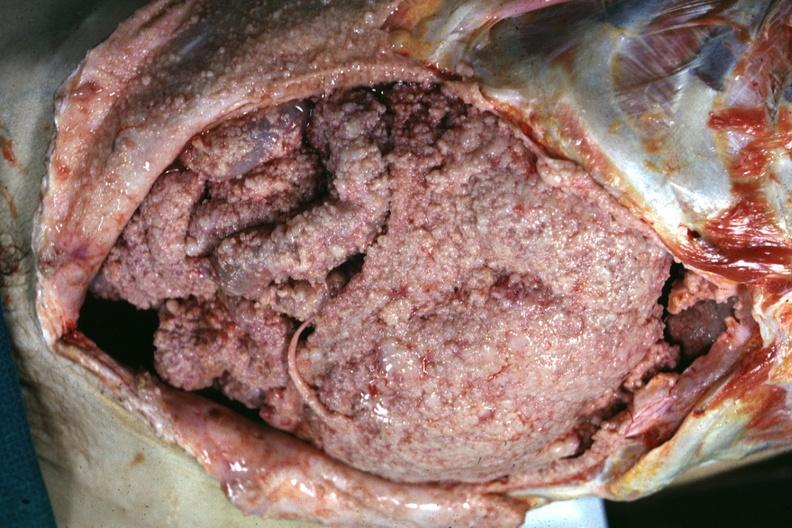does this image show opened abdomen showing tumor everywhere this also could be peritoneal carcinomatosis it looks the same?
Answer the question using a single word or phrase. Yes 